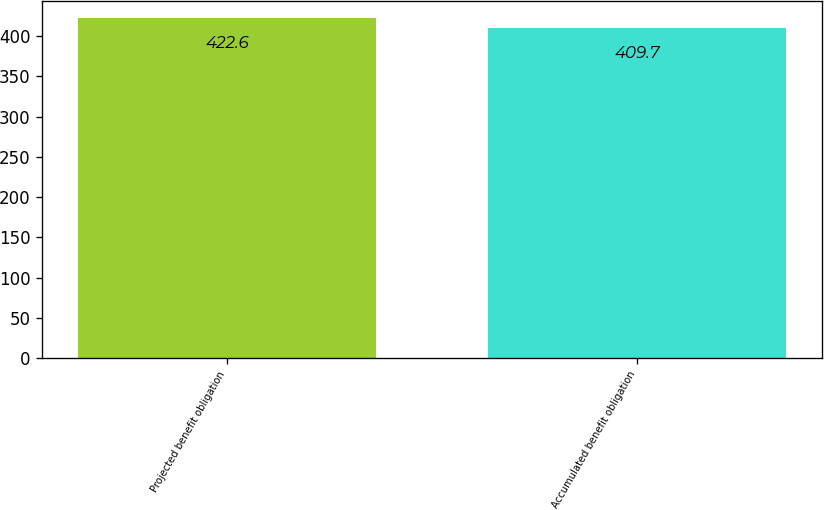<chart> <loc_0><loc_0><loc_500><loc_500><bar_chart><fcel>Projected benefit obligation<fcel>Accumulated benefit obligation<nl><fcel>422.6<fcel>409.7<nl></chart> 